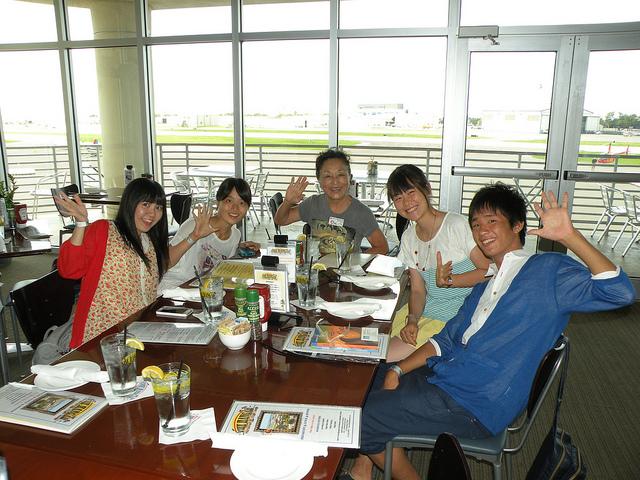Are they at a restaurant?
Give a very brief answer. Yes. What shape is the table?
Answer briefly. Rectangle. What continent do these people originate from?
Quick response, please. Asia. Do the woman have something in their mouths?
Keep it brief. No. What kind of drinks do they have?
Concise answer only. Water. How many people are sitting at the table?
Short answer required. 5. 